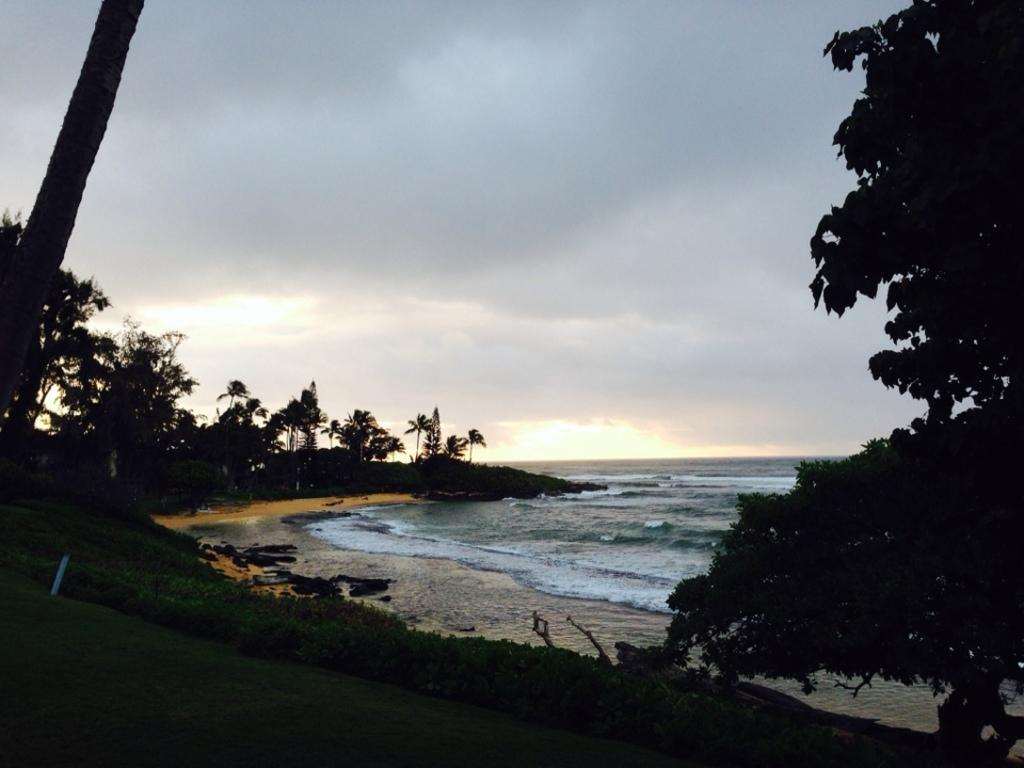What type of location is depicted in the image? There is a beach in the image. What can be seen surrounding the beach? There are trees around the beach in the image. What type of drink is your sister holding in the image? There is no sister or drink present in the image; it only features a beach and trees. 